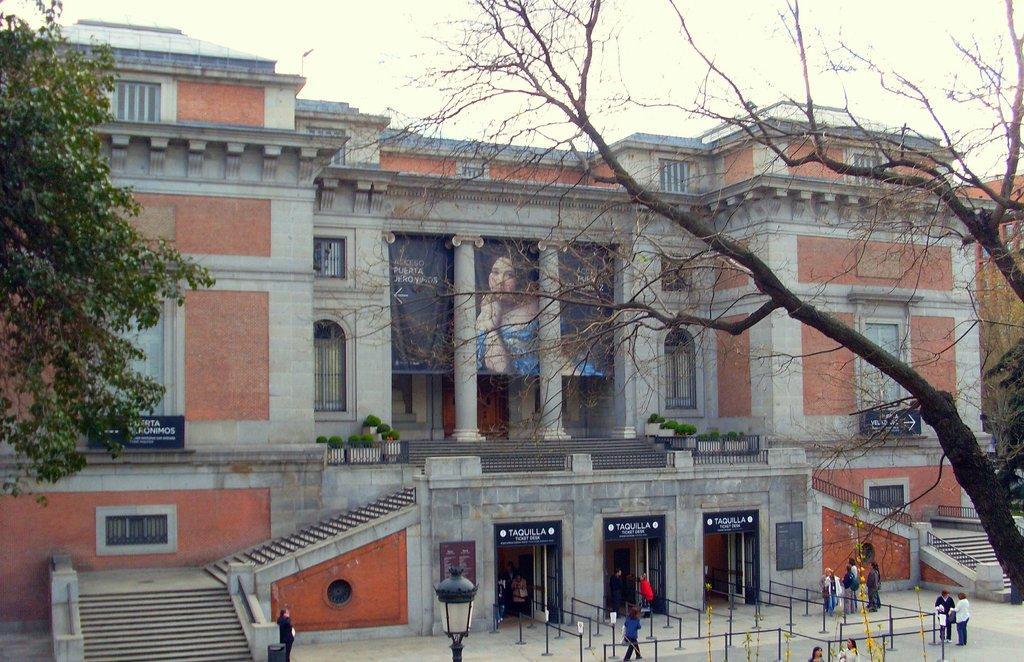Can you describe this image briefly? In this picture we can see trees, light and poles. There are people and we can see building, railings, banner, pillars, steps, boards and plants. In the background of the image we can see the sky. 